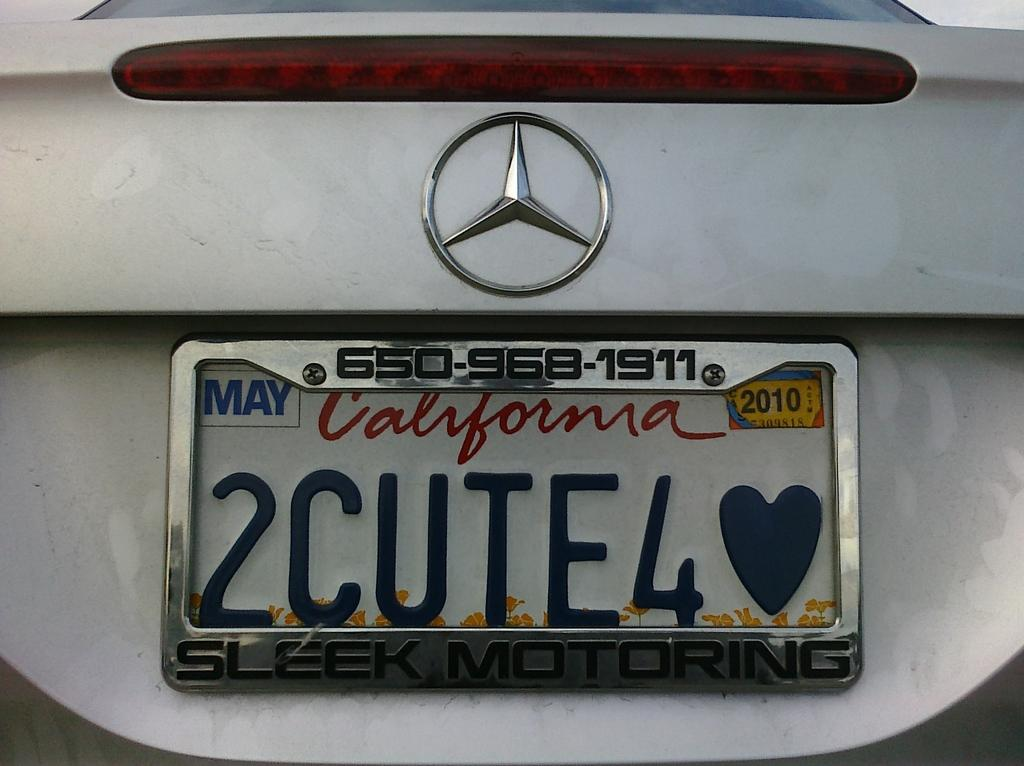<image>
Relay a brief, clear account of the picture shown. A Mercedes with a California tag on it that says 2Cute4<3. 